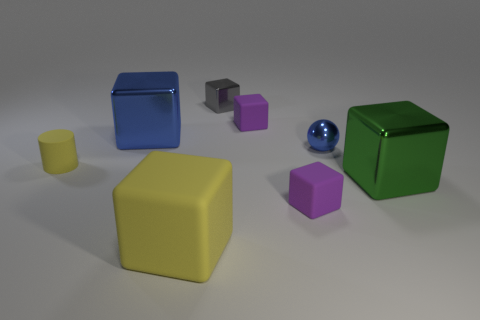There is a gray thing; does it have the same shape as the small purple matte thing behind the small blue sphere?
Ensure brevity in your answer.  Yes. There is a object that is both to the right of the gray metallic cube and behind the small ball; how big is it?
Your response must be concise. Small. What is the shape of the small gray metal thing?
Provide a succinct answer. Cube. Is there a matte block behind the metal cube in front of the matte cylinder?
Ensure brevity in your answer.  Yes. There is a small purple thing behind the rubber cylinder; how many large cubes are right of it?
Ensure brevity in your answer.  1. There is a green block that is the same size as the blue cube; what is it made of?
Provide a succinct answer. Metal. Is the shape of the large green object that is in front of the small gray thing the same as  the tiny yellow object?
Provide a short and direct response. No. Are there more small yellow cylinders that are on the left side of the small yellow matte object than small gray shiny blocks that are to the left of the blue shiny block?
Your answer should be compact. No. How many cylinders are made of the same material as the tiny gray block?
Your response must be concise. 0. Do the gray cube and the cylinder have the same size?
Keep it short and to the point. Yes. 